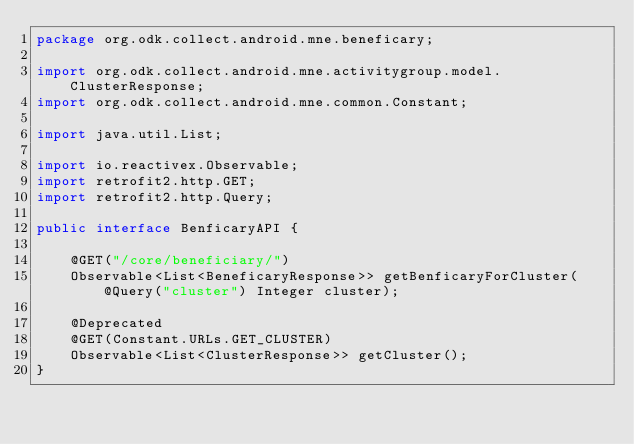<code> <loc_0><loc_0><loc_500><loc_500><_Java_>package org.odk.collect.android.mne.beneficary;

import org.odk.collect.android.mne.activitygroup.model.ClusterResponse;
import org.odk.collect.android.mne.common.Constant;

import java.util.List;

import io.reactivex.Observable;
import retrofit2.http.GET;
import retrofit2.http.Query;

public interface BenficaryAPI {

    @GET("/core/beneficiary/")
    Observable<List<BeneficaryResponse>> getBenficaryForCluster(@Query("cluster") Integer cluster);

    @Deprecated
    @GET(Constant.URLs.GET_CLUSTER)
    Observable<List<ClusterResponse>> getCluster();
}
</code> 